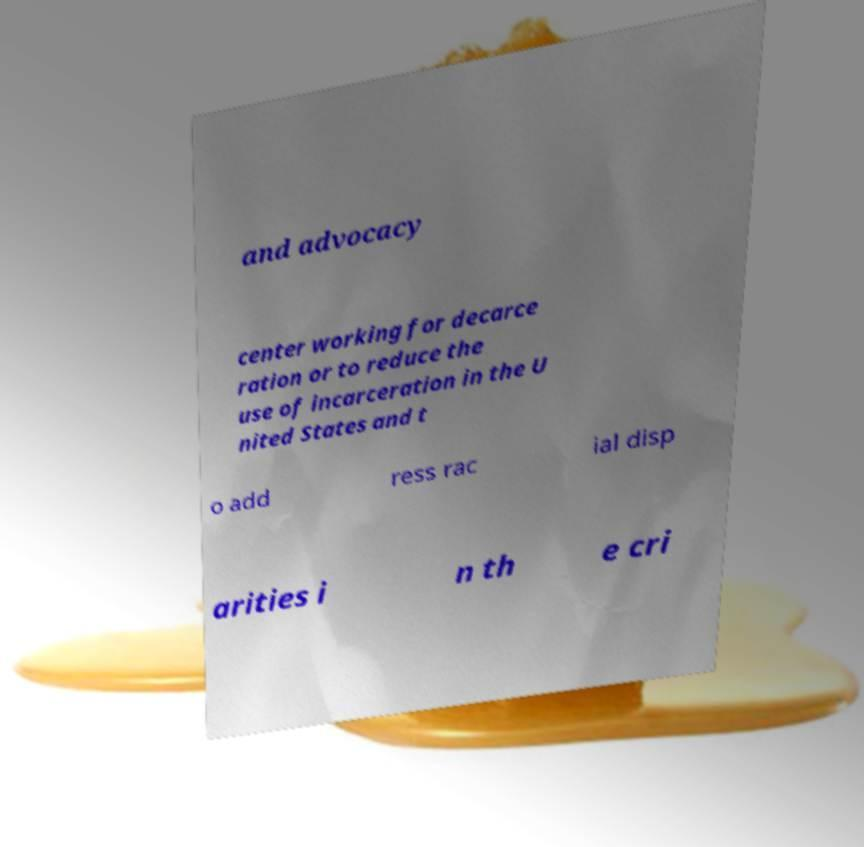Can you read and provide the text displayed in the image?This photo seems to have some interesting text. Can you extract and type it out for me? and advocacy center working for decarce ration or to reduce the use of incarceration in the U nited States and t o add ress rac ial disp arities i n th e cri 